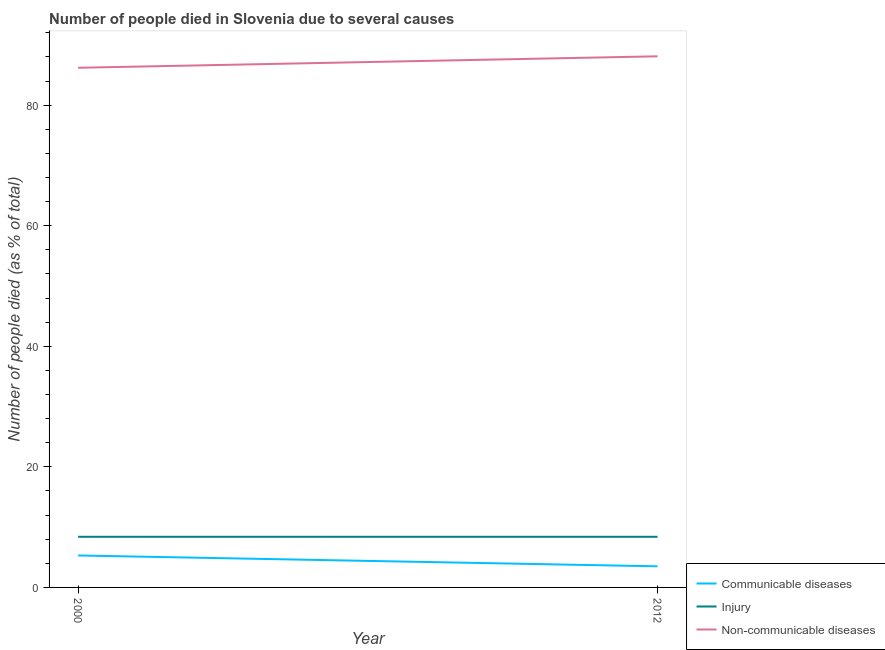Is the number of lines equal to the number of legend labels?
Provide a short and direct response. Yes. What is the number of people who dies of non-communicable diseases in 2000?
Provide a succinct answer. 86.2. Across all years, what is the minimum number of people who died of injury?
Keep it short and to the point. 8.4. In which year was the number of people who dies of non-communicable diseases maximum?
Keep it short and to the point. 2012. In which year was the number of people who dies of non-communicable diseases minimum?
Provide a short and direct response. 2000. What is the total number of people who dies of non-communicable diseases in the graph?
Make the answer very short. 174.3. What is the difference between the number of people who dies of non-communicable diseases in 2012 and the number of people who died of communicable diseases in 2000?
Ensure brevity in your answer.  82.8. What is the average number of people who died of injury per year?
Ensure brevity in your answer.  8.4. In the year 2012, what is the difference between the number of people who dies of non-communicable diseases and number of people who died of injury?
Ensure brevity in your answer.  79.7. What is the ratio of the number of people who died of communicable diseases in 2000 to that in 2012?
Make the answer very short. 1.51. Is the number of people who dies of non-communicable diseases strictly greater than the number of people who died of injury over the years?
Provide a succinct answer. Yes. Is the number of people who dies of non-communicable diseases strictly less than the number of people who died of communicable diseases over the years?
Your response must be concise. No. What is the difference between two consecutive major ticks on the Y-axis?
Make the answer very short. 20. How many legend labels are there?
Ensure brevity in your answer.  3. How are the legend labels stacked?
Offer a terse response. Vertical. What is the title of the graph?
Offer a terse response. Number of people died in Slovenia due to several causes. What is the label or title of the Y-axis?
Your answer should be compact. Number of people died (as % of total). What is the Number of people died (as % of total) of Communicable diseases in 2000?
Give a very brief answer. 5.3. What is the Number of people died (as % of total) in Non-communicable diseases in 2000?
Provide a succinct answer. 86.2. What is the Number of people died (as % of total) in Communicable diseases in 2012?
Your answer should be very brief. 3.5. What is the Number of people died (as % of total) in Injury in 2012?
Your response must be concise. 8.4. What is the Number of people died (as % of total) of Non-communicable diseases in 2012?
Give a very brief answer. 88.1. Across all years, what is the maximum Number of people died (as % of total) in Communicable diseases?
Offer a terse response. 5.3. Across all years, what is the maximum Number of people died (as % of total) of Non-communicable diseases?
Offer a terse response. 88.1. Across all years, what is the minimum Number of people died (as % of total) in Injury?
Your answer should be very brief. 8.4. Across all years, what is the minimum Number of people died (as % of total) of Non-communicable diseases?
Offer a very short reply. 86.2. What is the total Number of people died (as % of total) in Communicable diseases in the graph?
Provide a succinct answer. 8.8. What is the total Number of people died (as % of total) in Non-communicable diseases in the graph?
Keep it short and to the point. 174.3. What is the difference between the Number of people died (as % of total) in Communicable diseases in 2000 and that in 2012?
Offer a terse response. 1.8. What is the difference between the Number of people died (as % of total) of Non-communicable diseases in 2000 and that in 2012?
Keep it short and to the point. -1.9. What is the difference between the Number of people died (as % of total) in Communicable diseases in 2000 and the Number of people died (as % of total) in Non-communicable diseases in 2012?
Offer a very short reply. -82.8. What is the difference between the Number of people died (as % of total) in Injury in 2000 and the Number of people died (as % of total) in Non-communicable diseases in 2012?
Offer a terse response. -79.7. What is the average Number of people died (as % of total) of Injury per year?
Provide a succinct answer. 8.4. What is the average Number of people died (as % of total) of Non-communicable diseases per year?
Provide a short and direct response. 87.15. In the year 2000, what is the difference between the Number of people died (as % of total) in Communicable diseases and Number of people died (as % of total) in Non-communicable diseases?
Your response must be concise. -80.9. In the year 2000, what is the difference between the Number of people died (as % of total) of Injury and Number of people died (as % of total) of Non-communicable diseases?
Your answer should be very brief. -77.8. In the year 2012, what is the difference between the Number of people died (as % of total) in Communicable diseases and Number of people died (as % of total) in Injury?
Make the answer very short. -4.9. In the year 2012, what is the difference between the Number of people died (as % of total) of Communicable diseases and Number of people died (as % of total) of Non-communicable diseases?
Provide a short and direct response. -84.6. In the year 2012, what is the difference between the Number of people died (as % of total) in Injury and Number of people died (as % of total) in Non-communicable diseases?
Provide a short and direct response. -79.7. What is the ratio of the Number of people died (as % of total) of Communicable diseases in 2000 to that in 2012?
Your answer should be compact. 1.51. What is the ratio of the Number of people died (as % of total) of Non-communicable diseases in 2000 to that in 2012?
Offer a very short reply. 0.98. What is the difference between the highest and the second highest Number of people died (as % of total) of Communicable diseases?
Offer a very short reply. 1.8. What is the difference between the highest and the second highest Number of people died (as % of total) of Injury?
Provide a short and direct response. 0. What is the difference between the highest and the lowest Number of people died (as % of total) of Communicable diseases?
Your answer should be compact. 1.8. 